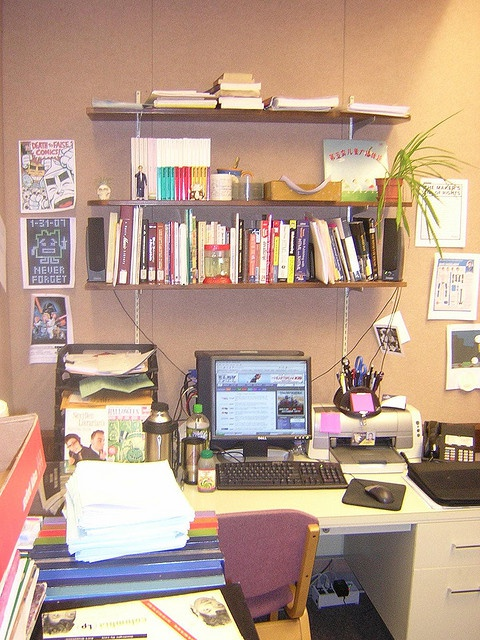Describe the objects in this image and their specific colors. I can see book in brown, white, gray, and tan tones, chair in brown, olive, and orange tones, tv in brown, lightblue, gray, and darkgray tones, potted plant in brown, khaki, ivory, and tan tones, and keyboard in brown, gray, black, and maroon tones in this image. 